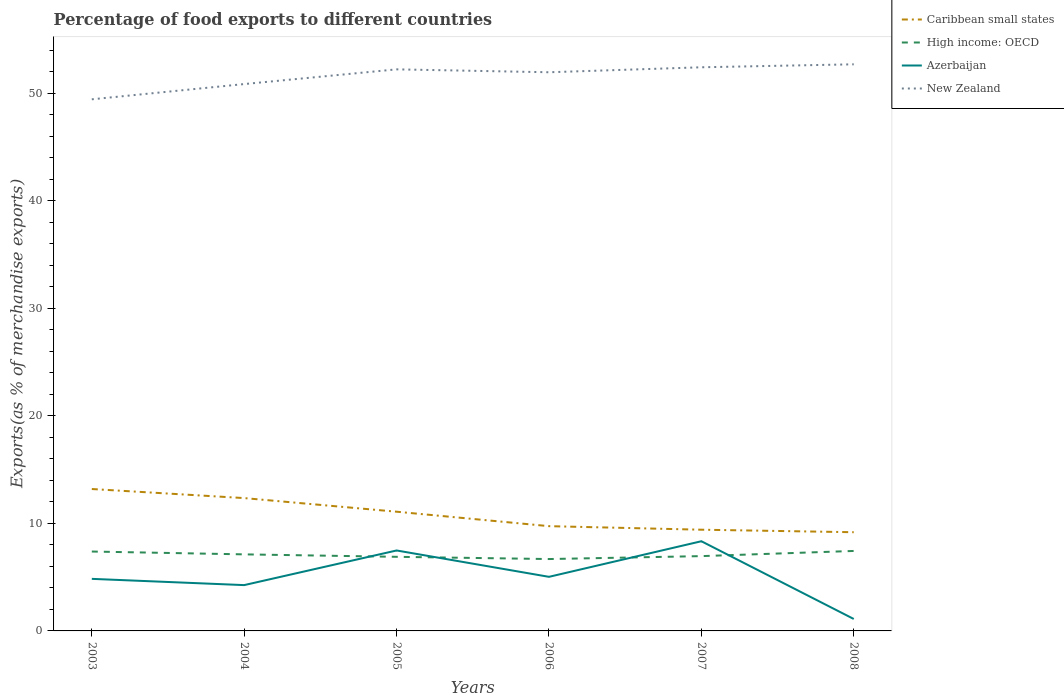Does the line corresponding to Azerbaijan intersect with the line corresponding to New Zealand?
Make the answer very short. No. Across all years, what is the maximum percentage of exports to different countries in Caribbean small states?
Ensure brevity in your answer.  9.18. In which year was the percentage of exports to different countries in Azerbaijan maximum?
Provide a succinct answer. 2008. What is the total percentage of exports to different countries in High income: OECD in the graph?
Make the answer very short. 0.7. What is the difference between the highest and the second highest percentage of exports to different countries in High income: OECD?
Ensure brevity in your answer.  0.75. How many lines are there?
Provide a short and direct response. 4. How many years are there in the graph?
Offer a very short reply. 6. Does the graph contain grids?
Offer a terse response. No. Where does the legend appear in the graph?
Your answer should be compact. Top right. What is the title of the graph?
Provide a succinct answer. Percentage of food exports to different countries. Does "Austria" appear as one of the legend labels in the graph?
Provide a short and direct response. No. What is the label or title of the Y-axis?
Your response must be concise. Exports(as % of merchandise exports). What is the Exports(as % of merchandise exports) of Caribbean small states in 2003?
Provide a succinct answer. 13.19. What is the Exports(as % of merchandise exports) of High income: OECD in 2003?
Offer a very short reply. 7.38. What is the Exports(as % of merchandise exports) in Azerbaijan in 2003?
Your response must be concise. 4.84. What is the Exports(as % of merchandise exports) in New Zealand in 2003?
Offer a very short reply. 49.42. What is the Exports(as % of merchandise exports) of Caribbean small states in 2004?
Give a very brief answer. 12.35. What is the Exports(as % of merchandise exports) of High income: OECD in 2004?
Your response must be concise. 7.12. What is the Exports(as % of merchandise exports) of Azerbaijan in 2004?
Make the answer very short. 4.26. What is the Exports(as % of merchandise exports) in New Zealand in 2004?
Provide a succinct answer. 50.84. What is the Exports(as % of merchandise exports) in Caribbean small states in 2005?
Your response must be concise. 11.08. What is the Exports(as % of merchandise exports) in High income: OECD in 2005?
Give a very brief answer. 6.89. What is the Exports(as % of merchandise exports) in Azerbaijan in 2005?
Provide a short and direct response. 7.48. What is the Exports(as % of merchandise exports) in New Zealand in 2005?
Provide a short and direct response. 52.21. What is the Exports(as % of merchandise exports) of Caribbean small states in 2006?
Your answer should be compact. 9.74. What is the Exports(as % of merchandise exports) of High income: OECD in 2006?
Provide a short and direct response. 6.68. What is the Exports(as % of merchandise exports) of Azerbaijan in 2006?
Provide a short and direct response. 5.03. What is the Exports(as % of merchandise exports) of New Zealand in 2006?
Keep it short and to the point. 51.94. What is the Exports(as % of merchandise exports) of Caribbean small states in 2007?
Keep it short and to the point. 9.41. What is the Exports(as % of merchandise exports) of High income: OECD in 2007?
Your answer should be compact. 6.95. What is the Exports(as % of merchandise exports) in Azerbaijan in 2007?
Provide a short and direct response. 8.34. What is the Exports(as % of merchandise exports) of New Zealand in 2007?
Offer a terse response. 52.4. What is the Exports(as % of merchandise exports) of Caribbean small states in 2008?
Your answer should be compact. 9.18. What is the Exports(as % of merchandise exports) of High income: OECD in 2008?
Your response must be concise. 7.43. What is the Exports(as % of merchandise exports) in Azerbaijan in 2008?
Provide a succinct answer. 1.11. What is the Exports(as % of merchandise exports) in New Zealand in 2008?
Your response must be concise. 52.68. Across all years, what is the maximum Exports(as % of merchandise exports) of Caribbean small states?
Offer a very short reply. 13.19. Across all years, what is the maximum Exports(as % of merchandise exports) in High income: OECD?
Your response must be concise. 7.43. Across all years, what is the maximum Exports(as % of merchandise exports) in Azerbaijan?
Keep it short and to the point. 8.34. Across all years, what is the maximum Exports(as % of merchandise exports) in New Zealand?
Your answer should be very brief. 52.68. Across all years, what is the minimum Exports(as % of merchandise exports) of Caribbean small states?
Give a very brief answer. 9.18. Across all years, what is the minimum Exports(as % of merchandise exports) in High income: OECD?
Your answer should be very brief. 6.68. Across all years, what is the minimum Exports(as % of merchandise exports) in Azerbaijan?
Offer a terse response. 1.11. Across all years, what is the minimum Exports(as % of merchandise exports) in New Zealand?
Keep it short and to the point. 49.42. What is the total Exports(as % of merchandise exports) in Caribbean small states in the graph?
Offer a very short reply. 64.95. What is the total Exports(as % of merchandise exports) of High income: OECD in the graph?
Your answer should be compact. 42.46. What is the total Exports(as % of merchandise exports) of Azerbaijan in the graph?
Offer a very short reply. 31.06. What is the total Exports(as % of merchandise exports) in New Zealand in the graph?
Offer a very short reply. 309.49. What is the difference between the Exports(as % of merchandise exports) in Caribbean small states in 2003 and that in 2004?
Give a very brief answer. 0.84. What is the difference between the Exports(as % of merchandise exports) in High income: OECD in 2003 and that in 2004?
Offer a very short reply. 0.26. What is the difference between the Exports(as % of merchandise exports) in Azerbaijan in 2003 and that in 2004?
Make the answer very short. 0.58. What is the difference between the Exports(as % of merchandise exports) of New Zealand in 2003 and that in 2004?
Provide a succinct answer. -1.42. What is the difference between the Exports(as % of merchandise exports) of Caribbean small states in 2003 and that in 2005?
Provide a short and direct response. 2.11. What is the difference between the Exports(as % of merchandise exports) of High income: OECD in 2003 and that in 2005?
Your answer should be compact. 0.49. What is the difference between the Exports(as % of merchandise exports) in Azerbaijan in 2003 and that in 2005?
Offer a very short reply. -2.64. What is the difference between the Exports(as % of merchandise exports) in New Zealand in 2003 and that in 2005?
Give a very brief answer. -2.79. What is the difference between the Exports(as % of merchandise exports) of Caribbean small states in 2003 and that in 2006?
Your answer should be compact. 3.45. What is the difference between the Exports(as % of merchandise exports) of High income: OECD in 2003 and that in 2006?
Provide a short and direct response. 0.7. What is the difference between the Exports(as % of merchandise exports) of Azerbaijan in 2003 and that in 2006?
Keep it short and to the point. -0.19. What is the difference between the Exports(as % of merchandise exports) of New Zealand in 2003 and that in 2006?
Provide a succinct answer. -2.51. What is the difference between the Exports(as % of merchandise exports) of Caribbean small states in 2003 and that in 2007?
Make the answer very short. 3.78. What is the difference between the Exports(as % of merchandise exports) in High income: OECD in 2003 and that in 2007?
Give a very brief answer. 0.43. What is the difference between the Exports(as % of merchandise exports) in Azerbaijan in 2003 and that in 2007?
Your answer should be compact. -3.5. What is the difference between the Exports(as % of merchandise exports) of New Zealand in 2003 and that in 2007?
Keep it short and to the point. -2.98. What is the difference between the Exports(as % of merchandise exports) in Caribbean small states in 2003 and that in 2008?
Your response must be concise. 4.02. What is the difference between the Exports(as % of merchandise exports) of High income: OECD in 2003 and that in 2008?
Provide a short and direct response. -0.05. What is the difference between the Exports(as % of merchandise exports) of Azerbaijan in 2003 and that in 2008?
Your answer should be very brief. 3.73. What is the difference between the Exports(as % of merchandise exports) of New Zealand in 2003 and that in 2008?
Your response must be concise. -3.25. What is the difference between the Exports(as % of merchandise exports) of Caribbean small states in 2004 and that in 2005?
Ensure brevity in your answer.  1.27. What is the difference between the Exports(as % of merchandise exports) of High income: OECD in 2004 and that in 2005?
Your answer should be compact. 0.23. What is the difference between the Exports(as % of merchandise exports) in Azerbaijan in 2004 and that in 2005?
Offer a very short reply. -3.22. What is the difference between the Exports(as % of merchandise exports) of New Zealand in 2004 and that in 2005?
Keep it short and to the point. -1.37. What is the difference between the Exports(as % of merchandise exports) in Caribbean small states in 2004 and that in 2006?
Keep it short and to the point. 2.61. What is the difference between the Exports(as % of merchandise exports) of High income: OECD in 2004 and that in 2006?
Give a very brief answer. 0.44. What is the difference between the Exports(as % of merchandise exports) of Azerbaijan in 2004 and that in 2006?
Your response must be concise. -0.77. What is the difference between the Exports(as % of merchandise exports) in New Zealand in 2004 and that in 2006?
Ensure brevity in your answer.  -1.1. What is the difference between the Exports(as % of merchandise exports) in Caribbean small states in 2004 and that in 2007?
Your response must be concise. 2.94. What is the difference between the Exports(as % of merchandise exports) of High income: OECD in 2004 and that in 2007?
Your response must be concise. 0.16. What is the difference between the Exports(as % of merchandise exports) of Azerbaijan in 2004 and that in 2007?
Your answer should be very brief. -4.08. What is the difference between the Exports(as % of merchandise exports) in New Zealand in 2004 and that in 2007?
Ensure brevity in your answer.  -1.56. What is the difference between the Exports(as % of merchandise exports) of Caribbean small states in 2004 and that in 2008?
Provide a short and direct response. 3.17. What is the difference between the Exports(as % of merchandise exports) of High income: OECD in 2004 and that in 2008?
Offer a very short reply. -0.32. What is the difference between the Exports(as % of merchandise exports) of Azerbaijan in 2004 and that in 2008?
Provide a succinct answer. 3.15. What is the difference between the Exports(as % of merchandise exports) of New Zealand in 2004 and that in 2008?
Provide a short and direct response. -1.84. What is the difference between the Exports(as % of merchandise exports) in Caribbean small states in 2005 and that in 2006?
Your response must be concise. 1.34. What is the difference between the Exports(as % of merchandise exports) in High income: OECD in 2005 and that in 2006?
Your answer should be very brief. 0.21. What is the difference between the Exports(as % of merchandise exports) of Azerbaijan in 2005 and that in 2006?
Give a very brief answer. 2.45. What is the difference between the Exports(as % of merchandise exports) in New Zealand in 2005 and that in 2006?
Keep it short and to the point. 0.27. What is the difference between the Exports(as % of merchandise exports) of Caribbean small states in 2005 and that in 2007?
Ensure brevity in your answer.  1.67. What is the difference between the Exports(as % of merchandise exports) of High income: OECD in 2005 and that in 2007?
Your response must be concise. -0.06. What is the difference between the Exports(as % of merchandise exports) in Azerbaijan in 2005 and that in 2007?
Your answer should be very brief. -0.86. What is the difference between the Exports(as % of merchandise exports) of New Zealand in 2005 and that in 2007?
Your answer should be very brief. -0.19. What is the difference between the Exports(as % of merchandise exports) in Caribbean small states in 2005 and that in 2008?
Ensure brevity in your answer.  1.91. What is the difference between the Exports(as % of merchandise exports) of High income: OECD in 2005 and that in 2008?
Keep it short and to the point. -0.55. What is the difference between the Exports(as % of merchandise exports) in Azerbaijan in 2005 and that in 2008?
Make the answer very short. 6.37. What is the difference between the Exports(as % of merchandise exports) of New Zealand in 2005 and that in 2008?
Offer a terse response. -0.47. What is the difference between the Exports(as % of merchandise exports) in Caribbean small states in 2006 and that in 2007?
Your answer should be compact. 0.33. What is the difference between the Exports(as % of merchandise exports) in High income: OECD in 2006 and that in 2007?
Offer a very short reply. -0.27. What is the difference between the Exports(as % of merchandise exports) in Azerbaijan in 2006 and that in 2007?
Your answer should be very brief. -3.31. What is the difference between the Exports(as % of merchandise exports) of New Zealand in 2006 and that in 2007?
Offer a very short reply. -0.46. What is the difference between the Exports(as % of merchandise exports) in Caribbean small states in 2006 and that in 2008?
Give a very brief answer. 0.56. What is the difference between the Exports(as % of merchandise exports) in High income: OECD in 2006 and that in 2008?
Offer a terse response. -0.75. What is the difference between the Exports(as % of merchandise exports) in Azerbaijan in 2006 and that in 2008?
Make the answer very short. 3.92. What is the difference between the Exports(as % of merchandise exports) of New Zealand in 2006 and that in 2008?
Provide a short and direct response. -0.74. What is the difference between the Exports(as % of merchandise exports) of Caribbean small states in 2007 and that in 2008?
Provide a short and direct response. 0.23. What is the difference between the Exports(as % of merchandise exports) in High income: OECD in 2007 and that in 2008?
Offer a very short reply. -0.48. What is the difference between the Exports(as % of merchandise exports) of Azerbaijan in 2007 and that in 2008?
Provide a short and direct response. 7.23. What is the difference between the Exports(as % of merchandise exports) of New Zealand in 2007 and that in 2008?
Give a very brief answer. -0.28. What is the difference between the Exports(as % of merchandise exports) of Caribbean small states in 2003 and the Exports(as % of merchandise exports) of High income: OECD in 2004?
Offer a very short reply. 6.08. What is the difference between the Exports(as % of merchandise exports) of Caribbean small states in 2003 and the Exports(as % of merchandise exports) of Azerbaijan in 2004?
Offer a very short reply. 8.93. What is the difference between the Exports(as % of merchandise exports) in Caribbean small states in 2003 and the Exports(as % of merchandise exports) in New Zealand in 2004?
Provide a succinct answer. -37.65. What is the difference between the Exports(as % of merchandise exports) of High income: OECD in 2003 and the Exports(as % of merchandise exports) of Azerbaijan in 2004?
Offer a terse response. 3.12. What is the difference between the Exports(as % of merchandise exports) in High income: OECD in 2003 and the Exports(as % of merchandise exports) in New Zealand in 2004?
Provide a succinct answer. -43.46. What is the difference between the Exports(as % of merchandise exports) in Azerbaijan in 2003 and the Exports(as % of merchandise exports) in New Zealand in 2004?
Give a very brief answer. -46. What is the difference between the Exports(as % of merchandise exports) of Caribbean small states in 2003 and the Exports(as % of merchandise exports) of High income: OECD in 2005?
Make the answer very short. 6.3. What is the difference between the Exports(as % of merchandise exports) in Caribbean small states in 2003 and the Exports(as % of merchandise exports) in Azerbaijan in 2005?
Your answer should be very brief. 5.71. What is the difference between the Exports(as % of merchandise exports) of Caribbean small states in 2003 and the Exports(as % of merchandise exports) of New Zealand in 2005?
Your answer should be compact. -39.02. What is the difference between the Exports(as % of merchandise exports) of High income: OECD in 2003 and the Exports(as % of merchandise exports) of Azerbaijan in 2005?
Provide a short and direct response. -0.1. What is the difference between the Exports(as % of merchandise exports) in High income: OECD in 2003 and the Exports(as % of merchandise exports) in New Zealand in 2005?
Your answer should be compact. -44.83. What is the difference between the Exports(as % of merchandise exports) of Azerbaijan in 2003 and the Exports(as % of merchandise exports) of New Zealand in 2005?
Make the answer very short. -47.37. What is the difference between the Exports(as % of merchandise exports) of Caribbean small states in 2003 and the Exports(as % of merchandise exports) of High income: OECD in 2006?
Offer a very short reply. 6.51. What is the difference between the Exports(as % of merchandise exports) in Caribbean small states in 2003 and the Exports(as % of merchandise exports) in Azerbaijan in 2006?
Provide a short and direct response. 8.16. What is the difference between the Exports(as % of merchandise exports) in Caribbean small states in 2003 and the Exports(as % of merchandise exports) in New Zealand in 2006?
Ensure brevity in your answer.  -38.75. What is the difference between the Exports(as % of merchandise exports) of High income: OECD in 2003 and the Exports(as % of merchandise exports) of Azerbaijan in 2006?
Provide a short and direct response. 2.35. What is the difference between the Exports(as % of merchandise exports) of High income: OECD in 2003 and the Exports(as % of merchandise exports) of New Zealand in 2006?
Your answer should be very brief. -44.56. What is the difference between the Exports(as % of merchandise exports) of Azerbaijan in 2003 and the Exports(as % of merchandise exports) of New Zealand in 2006?
Give a very brief answer. -47.1. What is the difference between the Exports(as % of merchandise exports) of Caribbean small states in 2003 and the Exports(as % of merchandise exports) of High income: OECD in 2007?
Your answer should be very brief. 6.24. What is the difference between the Exports(as % of merchandise exports) in Caribbean small states in 2003 and the Exports(as % of merchandise exports) in Azerbaijan in 2007?
Your answer should be very brief. 4.86. What is the difference between the Exports(as % of merchandise exports) in Caribbean small states in 2003 and the Exports(as % of merchandise exports) in New Zealand in 2007?
Ensure brevity in your answer.  -39.21. What is the difference between the Exports(as % of merchandise exports) in High income: OECD in 2003 and the Exports(as % of merchandise exports) in Azerbaijan in 2007?
Your answer should be compact. -0.96. What is the difference between the Exports(as % of merchandise exports) in High income: OECD in 2003 and the Exports(as % of merchandise exports) in New Zealand in 2007?
Your response must be concise. -45.02. What is the difference between the Exports(as % of merchandise exports) of Azerbaijan in 2003 and the Exports(as % of merchandise exports) of New Zealand in 2007?
Keep it short and to the point. -47.56. What is the difference between the Exports(as % of merchandise exports) of Caribbean small states in 2003 and the Exports(as % of merchandise exports) of High income: OECD in 2008?
Provide a succinct answer. 5.76. What is the difference between the Exports(as % of merchandise exports) in Caribbean small states in 2003 and the Exports(as % of merchandise exports) in Azerbaijan in 2008?
Your response must be concise. 12.08. What is the difference between the Exports(as % of merchandise exports) in Caribbean small states in 2003 and the Exports(as % of merchandise exports) in New Zealand in 2008?
Your response must be concise. -39.48. What is the difference between the Exports(as % of merchandise exports) in High income: OECD in 2003 and the Exports(as % of merchandise exports) in Azerbaijan in 2008?
Offer a very short reply. 6.27. What is the difference between the Exports(as % of merchandise exports) in High income: OECD in 2003 and the Exports(as % of merchandise exports) in New Zealand in 2008?
Your answer should be very brief. -45.3. What is the difference between the Exports(as % of merchandise exports) of Azerbaijan in 2003 and the Exports(as % of merchandise exports) of New Zealand in 2008?
Provide a short and direct response. -47.84. What is the difference between the Exports(as % of merchandise exports) of Caribbean small states in 2004 and the Exports(as % of merchandise exports) of High income: OECD in 2005?
Provide a succinct answer. 5.46. What is the difference between the Exports(as % of merchandise exports) in Caribbean small states in 2004 and the Exports(as % of merchandise exports) in Azerbaijan in 2005?
Provide a short and direct response. 4.87. What is the difference between the Exports(as % of merchandise exports) of Caribbean small states in 2004 and the Exports(as % of merchandise exports) of New Zealand in 2005?
Your response must be concise. -39.86. What is the difference between the Exports(as % of merchandise exports) in High income: OECD in 2004 and the Exports(as % of merchandise exports) in Azerbaijan in 2005?
Give a very brief answer. -0.36. What is the difference between the Exports(as % of merchandise exports) of High income: OECD in 2004 and the Exports(as % of merchandise exports) of New Zealand in 2005?
Ensure brevity in your answer.  -45.09. What is the difference between the Exports(as % of merchandise exports) of Azerbaijan in 2004 and the Exports(as % of merchandise exports) of New Zealand in 2005?
Your answer should be compact. -47.95. What is the difference between the Exports(as % of merchandise exports) in Caribbean small states in 2004 and the Exports(as % of merchandise exports) in High income: OECD in 2006?
Offer a terse response. 5.67. What is the difference between the Exports(as % of merchandise exports) of Caribbean small states in 2004 and the Exports(as % of merchandise exports) of Azerbaijan in 2006?
Offer a terse response. 7.32. What is the difference between the Exports(as % of merchandise exports) of Caribbean small states in 2004 and the Exports(as % of merchandise exports) of New Zealand in 2006?
Offer a terse response. -39.59. What is the difference between the Exports(as % of merchandise exports) in High income: OECD in 2004 and the Exports(as % of merchandise exports) in Azerbaijan in 2006?
Provide a succinct answer. 2.09. What is the difference between the Exports(as % of merchandise exports) of High income: OECD in 2004 and the Exports(as % of merchandise exports) of New Zealand in 2006?
Your response must be concise. -44.82. What is the difference between the Exports(as % of merchandise exports) in Azerbaijan in 2004 and the Exports(as % of merchandise exports) in New Zealand in 2006?
Ensure brevity in your answer.  -47.68. What is the difference between the Exports(as % of merchandise exports) of Caribbean small states in 2004 and the Exports(as % of merchandise exports) of High income: OECD in 2007?
Offer a very short reply. 5.4. What is the difference between the Exports(as % of merchandise exports) in Caribbean small states in 2004 and the Exports(as % of merchandise exports) in Azerbaijan in 2007?
Offer a terse response. 4.01. What is the difference between the Exports(as % of merchandise exports) of Caribbean small states in 2004 and the Exports(as % of merchandise exports) of New Zealand in 2007?
Give a very brief answer. -40.05. What is the difference between the Exports(as % of merchandise exports) in High income: OECD in 2004 and the Exports(as % of merchandise exports) in Azerbaijan in 2007?
Provide a short and direct response. -1.22. What is the difference between the Exports(as % of merchandise exports) of High income: OECD in 2004 and the Exports(as % of merchandise exports) of New Zealand in 2007?
Your answer should be compact. -45.28. What is the difference between the Exports(as % of merchandise exports) in Azerbaijan in 2004 and the Exports(as % of merchandise exports) in New Zealand in 2007?
Make the answer very short. -48.14. What is the difference between the Exports(as % of merchandise exports) of Caribbean small states in 2004 and the Exports(as % of merchandise exports) of High income: OECD in 2008?
Keep it short and to the point. 4.91. What is the difference between the Exports(as % of merchandise exports) in Caribbean small states in 2004 and the Exports(as % of merchandise exports) in Azerbaijan in 2008?
Give a very brief answer. 11.24. What is the difference between the Exports(as % of merchandise exports) of Caribbean small states in 2004 and the Exports(as % of merchandise exports) of New Zealand in 2008?
Your response must be concise. -40.33. What is the difference between the Exports(as % of merchandise exports) in High income: OECD in 2004 and the Exports(as % of merchandise exports) in Azerbaijan in 2008?
Keep it short and to the point. 6.01. What is the difference between the Exports(as % of merchandise exports) in High income: OECD in 2004 and the Exports(as % of merchandise exports) in New Zealand in 2008?
Provide a short and direct response. -45.56. What is the difference between the Exports(as % of merchandise exports) in Azerbaijan in 2004 and the Exports(as % of merchandise exports) in New Zealand in 2008?
Offer a very short reply. -48.42. What is the difference between the Exports(as % of merchandise exports) of Caribbean small states in 2005 and the Exports(as % of merchandise exports) of High income: OECD in 2006?
Make the answer very short. 4.4. What is the difference between the Exports(as % of merchandise exports) in Caribbean small states in 2005 and the Exports(as % of merchandise exports) in Azerbaijan in 2006?
Your answer should be very brief. 6.05. What is the difference between the Exports(as % of merchandise exports) in Caribbean small states in 2005 and the Exports(as % of merchandise exports) in New Zealand in 2006?
Your answer should be compact. -40.86. What is the difference between the Exports(as % of merchandise exports) of High income: OECD in 2005 and the Exports(as % of merchandise exports) of Azerbaijan in 2006?
Give a very brief answer. 1.86. What is the difference between the Exports(as % of merchandise exports) of High income: OECD in 2005 and the Exports(as % of merchandise exports) of New Zealand in 2006?
Give a very brief answer. -45.05. What is the difference between the Exports(as % of merchandise exports) of Azerbaijan in 2005 and the Exports(as % of merchandise exports) of New Zealand in 2006?
Ensure brevity in your answer.  -44.46. What is the difference between the Exports(as % of merchandise exports) in Caribbean small states in 2005 and the Exports(as % of merchandise exports) in High income: OECD in 2007?
Provide a succinct answer. 4.13. What is the difference between the Exports(as % of merchandise exports) of Caribbean small states in 2005 and the Exports(as % of merchandise exports) of Azerbaijan in 2007?
Provide a short and direct response. 2.75. What is the difference between the Exports(as % of merchandise exports) in Caribbean small states in 2005 and the Exports(as % of merchandise exports) in New Zealand in 2007?
Your answer should be very brief. -41.32. What is the difference between the Exports(as % of merchandise exports) in High income: OECD in 2005 and the Exports(as % of merchandise exports) in Azerbaijan in 2007?
Provide a short and direct response. -1.45. What is the difference between the Exports(as % of merchandise exports) in High income: OECD in 2005 and the Exports(as % of merchandise exports) in New Zealand in 2007?
Offer a terse response. -45.51. What is the difference between the Exports(as % of merchandise exports) of Azerbaijan in 2005 and the Exports(as % of merchandise exports) of New Zealand in 2007?
Your answer should be compact. -44.92. What is the difference between the Exports(as % of merchandise exports) of Caribbean small states in 2005 and the Exports(as % of merchandise exports) of High income: OECD in 2008?
Give a very brief answer. 3.65. What is the difference between the Exports(as % of merchandise exports) of Caribbean small states in 2005 and the Exports(as % of merchandise exports) of Azerbaijan in 2008?
Make the answer very short. 9.97. What is the difference between the Exports(as % of merchandise exports) of Caribbean small states in 2005 and the Exports(as % of merchandise exports) of New Zealand in 2008?
Provide a succinct answer. -41.59. What is the difference between the Exports(as % of merchandise exports) of High income: OECD in 2005 and the Exports(as % of merchandise exports) of Azerbaijan in 2008?
Provide a short and direct response. 5.78. What is the difference between the Exports(as % of merchandise exports) of High income: OECD in 2005 and the Exports(as % of merchandise exports) of New Zealand in 2008?
Your answer should be compact. -45.79. What is the difference between the Exports(as % of merchandise exports) of Azerbaijan in 2005 and the Exports(as % of merchandise exports) of New Zealand in 2008?
Ensure brevity in your answer.  -45.2. What is the difference between the Exports(as % of merchandise exports) in Caribbean small states in 2006 and the Exports(as % of merchandise exports) in High income: OECD in 2007?
Offer a very short reply. 2.79. What is the difference between the Exports(as % of merchandise exports) of Caribbean small states in 2006 and the Exports(as % of merchandise exports) of Azerbaijan in 2007?
Offer a terse response. 1.4. What is the difference between the Exports(as % of merchandise exports) of Caribbean small states in 2006 and the Exports(as % of merchandise exports) of New Zealand in 2007?
Your answer should be very brief. -42.66. What is the difference between the Exports(as % of merchandise exports) in High income: OECD in 2006 and the Exports(as % of merchandise exports) in Azerbaijan in 2007?
Give a very brief answer. -1.66. What is the difference between the Exports(as % of merchandise exports) in High income: OECD in 2006 and the Exports(as % of merchandise exports) in New Zealand in 2007?
Provide a succinct answer. -45.72. What is the difference between the Exports(as % of merchandise exports) in Azerbaijan in 2006 and the Exports(as % of merchandise exports) in New Zealand in 2007?
Give a very brief answer. -47.37. What is the difference between the Exports(as % of merchandise exports) of Caribbean small states in 2006 and the Exports(as % of merchandise exports) of High income: OECD in 2008?
Provide a succinct answer. 2.3. What is the difference between the Exports(as % of merchandise exports) of Caribbean small states in 2006 and the Exports(as % of merchandise exports) of Azerbaijan in 2008?
Your answer should be compact. 8.63. What is the difference between the Exports(as % of merchandise exports) of Caribbean small states in 2006 and the Exports(as % of merchandise exports) of New Zealand in 2008?
Your answer should be compact. -42.94. What is the difference between the Exports(as % of merchandise exports) of High income: OECD in 2006 and the Exports(as % of merchandise exports) of Azerbaijan in 2008?
Give a very brief answer. 5.57. What is the difference between the Exports(as % of merchandise exports) in High income: OECD in 2006 and the Exports(as % of merchandise exports) in New Zealand in 2008?
Offer a terse response. -46. What is the difference between the Exports(as % of merchandise exports) of Azerbaijan in 2006 and the Exports(as % of merchandise exports) of New Zealand in 2008?
Your response must be concise. -47.65. What is the difference between the Exports(as % of merchandise exports) in Caribbean small states in 2007 and the Exports(as % of merchandise exports) in High income: OECD in 2008?
Offer a very short reply. 1.97. What is the difference between the Exports(as % of merchandise exports) in Caribbean small states in 2007 and the Exports(as % of merchandise exports) in Azerbaijan in 2008?
Offer a very short reply. 8.3. What is the difference between the Exports(as % of merchandise exports) of Caribbean small states in 2007 and the Exports(as % of merchandise exports) of New Zealand in 2008?
Your answer should be compact. -43.27. What is the difference between the Exports(as % of merchandise exports) in High income: OECD in 2007 and the Exports(as % of merchandise exports) in Azerbaijan in 2008?
Keep it short and to the point. 5.84. What is the difference between the Exports(as % of merchandise exports) of High income: OECD in 2007 and the Exports(as % of merchandise exports) of New Zealand in 2008?
Ensure brevity in your answer.  -45.72. What is the difference between the Exports(as % of merchandise exports) in Azerbaijan in 2007 and the Exports(as % of merchandise exports) in New Zealand in 2008?
Your answer should be compact. -44.34. What is the average Exports(as % of merchandise exports) of Caribbean small states per year?
Your response must be concise. 10.83. What is the average Exports(as % of merchandise exports) of High income: OECD per year?
Ensure brevity in your answer.  7.08. What is the average Exports(as % of merchandise exports) in Azerbaijan per year?
Your response must be concise. 5.18. What is the average Exports(as % of merchandise exports) in New Zealand per year?
Your answer should be compact. 51.58. In the year 2003, what is the difference between the Exports(as % of merchandise exports) in Caribbean small states and Exports(as % of merchandise exports) in High income: OECD?
Ensure brevity in your answer.  5.81. In the year 2003, what is the difference between the Exports(as % of merchandise exports) of Caribbean small states and Exports(as % of merchandise exports) of Azerbaijan?
Ensure brevity in your answer.  8.35. In the year 2003, what is the difference between the Exports(as % of merchandise exports) of Caribbean small states and Exports(as % of merchandise exports) of New Zealand?
Provide a succinct answer. -36.23. In the year 2003, what is the difference between the Exports(as % of merchandise exports) in High income: OECD and Exports(as % of merchandise exports) in Azerbaijan?
Provide a short and direct response. 2.54. In the year 2003, what is the difference between the Exports(as % of merchandise exports) of High income: OECD and Exports(as % of merchandise exports) of New Zealand?
Your answer should be compact. -42.04. In the year 2003, what is the difference between the Exports(as % of merchandise exports) in Azerbaijan and Exports(as % of merchandise exports) in New Zealand?
Ensure brevity in your answer.  -44.58. In the year 2004, what is the difference between the Exports(as % of merchandise exports) of Caribbean small states and Exports(as % of merchandise exports) of High income: OECD?
Provide a short and direct response. 5.23. In the year 2004, what is the difference between the Exports(as % of merchandise exports) of Caribbean small states and Exports(as % of merchandise exports) of Azerbaijan?
Offer a very short reply. 8.09. In the year 2004, what is the difference between the Exports(as % of merchandise exports) of Caribbean small states and Exports(as % of merchandise exports) of New Zealand?
Your answer should be very brief. -38.49. In the year 2004, what is the difference between the Exports(as % of merchandise exports) in High income: OECD and Exports(as % of merchandise exports) in Azerbaijan?
Offer a very short reply. 2.86. In the year 2004, what is the difference between the Exports(as % of merchandise exports) in High income: OECD and Exports(as % of merchandise exports) in New Zealand?
Ensure brevity in your answer.  -43.72. In the year 2004, what is the difference between the Exports(as % of merchandise exports) of Azerbaijan and Exports(as % of merchandise exports) of New Zealand?
Keep it short and to the point. -46.58. In the year 2005, what is the difference between the Exports(as % of merchandise exports) of Caribbean small states and Exports(as % of merchandise exports) of High income: OECD?
Your response must be concise. 4.19. In the year 2005, what is the difference between the Exports(as % of merchandise exports) in Caribbean small states and Exports(as % of merchandise exports) in Azerbaijan?
Provide a short and direct response. 3.6. In the year 2005, what is the difference between the Exports(as % of merchandise exports) in Caribbean small states and Exports(as % of merchandise exports) in New Zealand?
Your answer should be compact. -41.13. In the year 2005, what is the difference between the Exports(as % of merchandise exports) of High income: OECD and Exports(as % of merchandise exports) of Azerbaijan?
Give a very brief answer. -0.59. In the year 2005, what is the difference between the Exports(as % of merchandise exports) in High income: OECD and Exports(as % of merchandise exports) in New Zealand?
Make the answer very short. -45.32. In the year 2005, what is the difference between the Exports(as % of merchandise exports) of Azerbaijan and Exports(as % of merchandise exports) of New Zealand?
Make the answer very short. -44.73. In the year 2006, what is the difference between the Exports(as % of merchandise exports) in Caribbean small states and Exports(as % of merchandise exports) in High income: OECD?
Give a very brief answer. 3.06. In the year 2006, what is the difference between the Exports(as % of merchandise exports) in Caribbean small states and Exports(as % of merchandise exports) in Azerbaijan?
Your response must be concise. 4.71. In the year 2006, what is the difference between the Exports(as % of merchandise exports) in Caribbean small states and Exports(as % of merchandise exports) in New Zealand?
Give a very brief answer. -42.2. In the year 2006, what is the difference between the Exports(as % of merchandise exports) of High income: OECD and Exports(as % of merchandise exports) of Azerbaijan?
Keep it short and to the point. 1.65. In the year 2006, what is the difference between the Exports(as % of merchandise exports) of High income: OECD and Exports(as % of merchandise exports) of New Zealand?
Your response must be concise. -45.26. In the year 2006, what is the difference between the Exports(as % of merchandise exports) in Azerbaijan and Exports(as % of merchandise exports) in New Zealand?
Ensure brevity in your answer.  -46.91. In the year 2007, what is the difference between the Exports(as % of merchandise exports) in Caribbean small states and Exports(as % of merchandise exports) in High income: OECD?
Your response must be concise. 2.46. In the year 2007, what is the difference between the Exports(as % of merchandise exports) in Caribbean small states and Exports(as % of merchandise exports) in Azerbaijan?
Provide a short and direct response. 1.07. In the year 2007, what is the difference between the Exports(as % of merchandise exports) of Caribbean small states and Exports(as % of merchandise exports) of New Zealand?
Ensure brevity in your answer.  -42.99. In the year 2007, what is the difference between the Exports(as % of merchandise exports) in High income: OECD and Exports(as % of merchandise exports) in Azerbaijan?
Offer a terse response. -1.38. In the year 2007, what is the difference between the Exports(as % of merchandise exports) in High income: OECD and Exports(as % of merchandise exports) in New Zealand?
Offer a terse response. -45.45. In the year 2007, what is the difference between the Exports(as % of merchandise exports) in Azerbaijan and Exports(as % of merchandise exports) in New Zealand?
Your response must be concise. -44.06. In the year 2008, what is the difference between the Exports(as % of merchandise exports) in Caribbean small states and Exports(as % of merchandise exports) in High income: OECD?
Your response must be concise. 1.74. In the year 2008, what is the difference between the Exports(as % of merchandise exports) of Caribbean small states and Exports(as % of merchandise exports) of Azerbaijan?
Your answer should be very brief. 8.07. In the year 2008, what is the difference between the Exports(as % of merchandise exports) in Caribbean small states and Exports(as % of merchandise exports) in New Zealand?
Your answer should be compact. -43.5. In the year 2008, what is the difference between the Exports(as % of merchandise exports) in High income: OECD and Exports(as % of merchandise exports) in Azerbaijan?
Provide a succinct answer. 6.32. In the year 2008, what is the difference between the Exports(as % of merchandise exports) of High income: OECD and Exports(as % of merchandise exports) of New Zealand?
Your answer should be very brief. -45.24. In the year 2008, what is the difference between the Exports(as % of merchandise exports) in Azerbaijan and Exports(as % of merchandise exports) in New Zealand?
Provide a short and direct response. -51.57. What is the ratio of the Exports(as % of merchandise exports) of Caribbean small states in 2003 to that in 2004?
Your answer should be very brief. 1.07. What is the ratio of the Exports(as % of merchandise exports) in High income: OECD in 2003 to that in 2004?
Give a very brief answer. 1.04. What is the ratio of the Exports(as % of merchandise exports) of Azerbaijan in 2003 to that in 2004?
Ensure brevity in your answer.  1.14. What is the ratio of the Exports(as % of merchandise exports) in New Zealand in 2003 to that in 2004?
Provide a short and direct response. 0.97. What is the ratio of the Exports(as % of merchandise exports) in Caribbean small states in 2003 to that in 2005?
Provide a succinct answer. 1.19. What is the ratio of the Exports(as % of merchandise exports) in High income: OECD in 2003 to that in 2005?
Your response must be concise. 1.07. What is the ratio of the Exports(as % of merchandise exports) of Azerbaijan in 2003 to that in 2005?
Provide a succinct answer. 0.65. What is the ratio of the Exports(as % of merchandise exports) in New Zealand in 2003 to that in 2005?
Keep it short and to the point. 0.95. What is the ratio of the Exports(as % of merchandise exports) in Caribbean small states in 2003 to that in 2006?
Make the answer very short. 1.35. What is the ratio of the Exports(as % of merchandise exports) in High income: OECD in 2003 to that in 2006?
Make the answer very short. 1.1. What is the ratio of the Exports(as % of merchandise exports) in Azerbaijan in 2003 to that in 2006?
Provide a short and direct response. 0.96. What is the ratio of the Exports(as % of merchandise exports) of New Zealand in 2003 to that in 2006?
Your response must be concise. 0.95. What is the ratio of the Exports(as % of merchandise exports) in Caribbean small states in 2003 to that in 2007?
Keep it short and to the point. 1.4. What is the ratio of the Exports(as % of merchandise exports) of High income: OECD in 2003 to that in 2007?
Offer a very short reply. 1.06. What is the ratio of the Exports(as % of merchandise exports) in Azerbaijan in 2003 to that in 2007?
Give a very brief answer. 0.58. What is the ratio of the Exports(as % of merchandise exports) of New Zealand in 2003 to that in 2007?
Provide a succinct answer. 0.94. What is the ratio of the Exports(as % of merchandise exports) of Caribbean small states in 2003 to that in 2008?
Provide a short and direct response. 1.44. What is the ratio of the Exports(as % of merchandise exports) in High income: OECD in 2003 to that in 2008?
Ensure brevity in your answer.  0.99. What is the ratio of the Exports(as % of merchandise exports) of Azerbaijan in 2003 to that in 2008?
Give a very brief answer. 4.36. What is the ratio of the Exports(as % of merchandise exports) in New Zealand in 2003 to that in 2008?
Offer a terse response. 0.94. What is the ratio of the Exports(as % of merchandise exports) in Caribbean small states in 2004 to that in 2005?
Ensure brevity in your answer.  1.11. What is the ratio of the Exports(as % of merchandise exports) in High income: OECD in 2004 to that in 2005?
Give a very brief answer. 1.03. What is the ratio of the Exports(as % of merchandise exports) of Azerbaijan in 2004 to that in 2005?
Keep it short and to the point. 0.57. What is the ratio of the Exports(as % of merchandise exports) in New Zealand in 2004 to that in 2005?
Give a very brief answer. 0.97. What is the ratio of the Exports(as % of merchandise exports) of Caribbean small states in 2004 to that in 2006?
Provide a short and direct response. 1.27. What is the ratio of the Exports(as % of merchandise exports) in High income: OECD in 2004 to that in 2006?
Your answer should be compact. 1.07. What is the ratio of the Exports(as % of merchandise exports) of Azerbaijan in 2004 to that in 2006?
Your response must be concise. 0.85. What is the ratio of the Exports(as % of merchandise exports) of New Zealand in 2004 to that in 2006?
Your answer should be compact. 0.98. What is the ratio of the Exports(as % of merchandise exports) in Caribbean small states in 2004 to that in 2007?
Offer a very short reply. 1.31. What is the ratio of the Exports(as % of merchandise exports) of High income: OECD in 2004 to that in 2007?
Ensure brevity in your answer.  1.02. What is the ratio of the Exports(as % of merchandise exports) in Azerbaijan in 2004 to that in 2007?
Offer a very short reply. 0.51. What is the ratio of the Exports(as % of merchandise exports) of New Zealand in 2004 to that in 2007?
Keep it short and to the point. 0.97. What is the ratio of the Exports(as % of merchandise exports) of Caribbean small states in 2004 to that in 2008?
Ensure brevity in your answer.  1.35. What is the ratio of the Exports(as % of merchandise exports) of High income: OECD in 2004 to that in 2008?
Offer a terse response. 0.96. What is the ratio of the Exports(as % of merchandise exports) in Azerbaijan in 2004 to that in 2008?
Provide a succinct answer. 3.83. What is the ratio of the Exports(as % of merchandise exports) of New Zealand in 2004 to that in 2008?
Your answer should be very brief. 0.97. What is the ratio of the Exports(as % of merchandise exports) in Caribbean small states in 2005 to that in 2006?
Provide a short and direct response. 1.14. What is the ratio of the Exports(as % of merchandise exports) in High income: OECD in 2005 to that in 2006?
Provide a succinct answer. 1.03. What is the ratio of the Exports(as % of merchandise exports) in Azerbaijan in 2005 to that in 2006?
Your answer should be very brief. 1.49. What is the ratio of the Exports(as % of merchandise exports) of Caribbean small states in 2005 to that in 2007?
Offer a very short reply. 1.18. What is the ratio of the Exports(as % of merchandise exports) of High income: OECD in 2005 to that in 2007?
Keep it short and to the point. 0.99. What is the ratio of the Exports(as % of merchandise exports) in Azerbaijan in 2005 to that in 2007?
Your response must be concise. 0.9. What is the ratio of the Exports(as % of merchandise exports) of New Zealand in 2005 to that in 2007?
Your response must be concise. 1. What is the ratio of the Exports(as % of merchandise exports) in Caribbean small states in 2005 to that in 2008?
Offer a very short reply. 1.21. What is the ratio of the Exports(as % of merchandise exports) of High income: OECD in 2005 to that in 2008?
Ensure brevity in your answer.  0.93. What is the ratio of the Exports(as % of merchandise exports) in Azerbaijan in 2005 to that in 2008?
Provide a succinct answer. 6.73. What is the ratio of the Exports(as % of merchandise exports) in New Zealand in 2005 to that in 2008?
Keep it short and to the point. 0.99. What is the ratio of the Exports(as % of merchandise exports) of Caribbean small states in 2006 to that in 2007?
Your answer should be compact. 1.04. What is the ratio of the Exports(as % of merchandise exports) in High income: OECD in 2006 to that in 2007?
Offer a very short reply. 0.96. What is the ratio of the Exports(as % of merchandise exports) of Azerbaijan in 2006 to that in 2007?
Make the answer very short. 0.6. What is the ratio of the Exports(as % of merchandise exports) of New Zealand in 2006 to that in 2007?
Give a very brief answer. 0.99. What is the ratio of the Exports(as % of merchandise exports) of Caribbean small states in 2006 to that in 2008?
Offer a terse response. 1.06. What is the ratio of the Exports(as % of merchandise exports) in High income: OECD in 2006 to that in 2008?
Your answer should be very brief. 0.9. What is the ratio of the Exports(as % of merchandise exports) of Azerbaijan in 2006 to that in 2008?
Your answer should be compact. 4.53. What is the ratio of the Exports(as % of merchandise exports) of Caribbean small states in 2007 to that in 2008?
Give a very brief answer. 1.03. What is the ratio of the Exports(as % of merchandise exports) in High income: OECD in 2007 to that in 2008?
Give a very brief answer. 0.94. What is the ratio of the Exports(as % of merchandise exports) of Azerbaijan in 2007 to that in 2008?
Your response must be concise. 7.5. What is the difference between the highest and the second highest Exports(as % of merchandise exports) of Caribbean small states?
Offer a terse response. 0.84. What is the difference between the highest and the second highest Exports(as % of merchandise exports) in High income: OECD?
Offer a terse response. 0.05. What is the difference between the highest and the second highest Exports(as % of merchandise exports) of Azerbaijan?
Provide a short and direct response. 0.86. What is the difference between the highest and the second highest Exports(as % of merchandise exports) of New Zealand?
Offer a terse response. 0.28. What is the difference between the highest and the lowest Exports(as % of merchandise exports) of Caribbean small states?
Your answer should be very brief. 4.02. What is the difference between the highest and the lowest Exports(as % of merchandise exports) of High income: OECD?
Give a very brief answer. 0.75. What is the difference between the highest and the lowest Exports(as % of merchandise exports) of Azerbaijan?
Offer a terse response. 7.23. What is the difference between the highest and the lowest Exports(as % of merchandise exports) in New Zealand?
Keep it short and to the point. 3.25. 